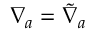Convert formula to latex. <formula><loc_0><loc_0><loc_500><loc_500>\nabla _ { a } = \tilde { \nabla } _ { a }</formula> 